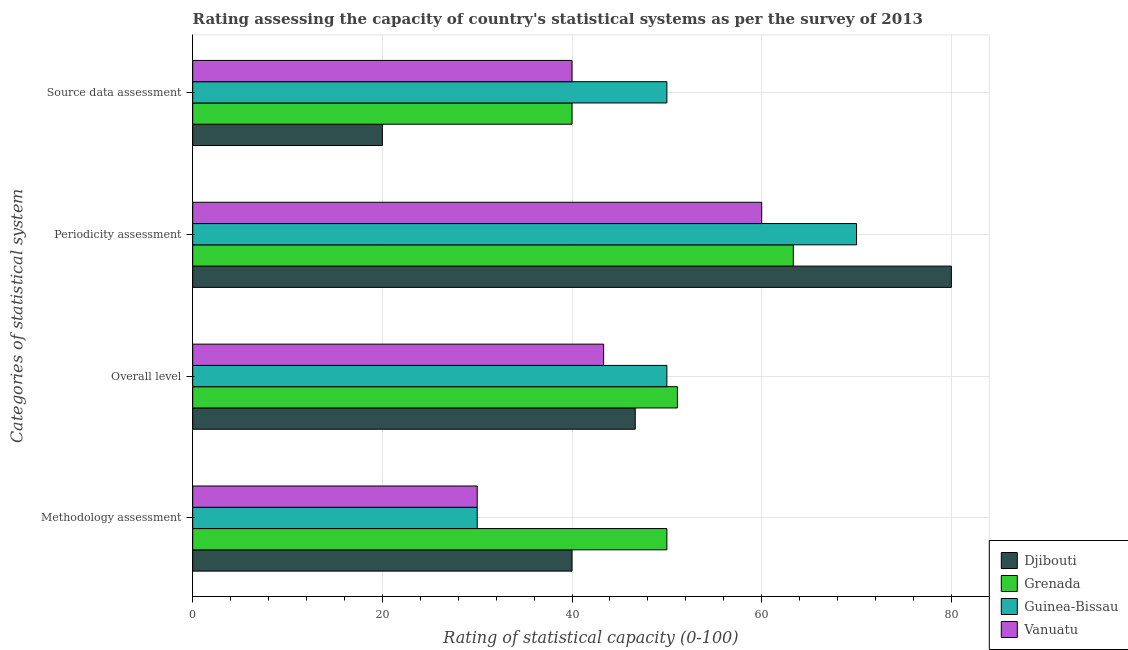How many different coloured bars are there?
Offer a very short reply. 4. Are the number of bars on each tick of the Y-axis equal?
Offer a terse response. Yes. How many bars are there on the 3rd tick from the top?
Your response must be concise. 4. How many bars are there on the 4th tick from the bottom?
Keep it short and to the point. 4. What is the label of the 1st group of bars from the top?
Provide a short and direct response. Source data assessment. What is the overall level rating in Grenada?
Provide a short and direct response. 51.11. Across all countries, what is the maximum methodology assessment rating?
Make the answer very short. 50. Across all countries, what is the minimum source data assessment rating?
Your answer should be very brief. 20. In which country was the methodology assessment rating maximum?
Offer a terse response. Grenada. In which country was the overall level rating minimum?
Provide a succinct answer. Vanuatu. What is the total methodology assessment rating in the graph?
Ensure brevity in your answer.  150. What is the difference between the source data assessment rating in Guinea-Bissau and that in Vanuatu?
Keep it short and to the point. 10. What is the difference between the methodology assessment rating in Vanuatu and the overall level rating in Grenada?
Offer a terse response. -21.11. What is the average overall level rating per country?
Provide a succinct answer. 47.78. What is the difference between the source data assessment rating and methodology assessment rating in Djibouti?
Provide a succinct answer. -20. What is the ratio of the methodology assessment rating in Grenada to that in Djibouti?
Ensure brevity in your answer.  1.25. Is the methodology assessment rating in Djibouti less than that in Guinea-Bissau?
Offer a very short reply. No. What is the difference between the highest and the second highest overall level rating?
Make the answer very short. 1.11. Is it the case that in every country, the sum of the source data assessment rating and periodicity assessment rating is greater than the sum of methodology assessment rating and overall level rating?
Offer a terse response. Yes. What does the 1st bar from the top in Methodology assessment represents?
Provide a short and direct response. Vanuatu. What does the 4th bar from the bottom in Overall level represents?
Your answer should be compact. Vanuatu. Are all the bars in the graph horizontal?
Keep it short and to the point. Yes. How many countries are there in the graph?
Your response must be concise. 4. What is the difference between two consecutive major ticks on the X-axis?
Offer a terse response. 20. Are the values on the major ticks of X-axis written in scientific E-notation?
Provide a succinct answer. No. Does the graph contain any zero values?
Keep it short and to the point. No. What is the title of the graph?
Ensure brevity in your answer.  Rating assessing the capacity of country's statistical systems as per the survey of 2013 . What is the label or title of the X-axis?
Your answer should be compact. Rating of statistical capacity (0-100). What is the label or title of the Y-axis?
Give a very brief answer. Categories of statistical system. What is the Rating of statistical capacity (0-100) in Djibouti in Methodology assessment?
Provide a succinct answer. 40. What is the Rating of statistical capacity (0-100) of Guinea-Bissau in Methodology assessment?
Offer a very short reply. 30. What is the Rating of statistical capacity (0-100) of Djibouti in Overall level?
Make the answer very short. 46.67. What is the Rating of statistical capacity (0-100) in Grenada in Overall level?
Your answer should be very brief. 51.11. What is the Rating of statistical capacity (0-100) in Guinea-Bissau in Overall level?
Provide a succinct answer. 50. What is the Rating of statistical capacity (0-100) of Vanuatu in Overall level?
Your response must be concise. 43.33. What is the Rating of statistical capacity (0-100) of Grenada in Periodicity assessment?
Your answer should be very brief. 63.33. What is the Rating of statistical capacity (0-100) of Djibouti in Source data assessment?
Your answer should be compact. 20. What is the Rating of statistical capacity (0-100) in Vanuatu in Source data assessment?
Give a very brief answer. 40. Across all Categories of statistical system, what is the maximum Rating of statistical capacity (0-100) of Djibouti?
Your answer should be compact. 80. Across all Categories of statistical system, what is the maximum Rating of statistical capacity (0-100) of Grenada?
Your response must be concise. 63.33. Across all Categories of statistical system, what is the maximum Rating of statistical capacity (0-100) of Guinea-Bissau?
Make the answer very short. 70. Across all Categories of statistical system, what is the maximum Rating of statistical capacity (0-100) of Vanuatu?
Ensure brevity in your answer.  60. What is the total Rating of statistical capacity (0-100) of Djibouti in the graph?
Your answer should be compact. 186.67. What is the total Rating of statistical capacity (0-100) of Grenada in the graph?
Provide a succinct answer. 204.44. What is the total Rating of statistical capacity (0-100) in Guinea-Bissau in the graph?
Your answer should be very brief. 200. What is the total Rating of statistical capacity (0-100) in Vanuatu in the graph?
Ensure brevity in your answer.  173.33. What is the difference between the Rating of statistical capacity (0-100) of Djibouti in Methodology assessment and that in Overall level?
Provide a succinct answer. -6.67. What is the difference between the Rating of statistical capacity (0-100) in Grenada in Methodology assessment and that in Overall level?
Ensure brevity in your answer.  -1.11. What is the difference between the Rating of statistical capacity (0-100) in Guinea-Bissau in Methodology assessment and that in Overall level?
Make the answer very short. -20. What is the difference between the Rating of statistical capacity (0-100) in Vanuatu in Methodology assessment and that in Overall level?
Your answer should be very brief. -13.33. What is the difference between the Rating of statistical capacity (0-100) of Grenada in Methodology assessment and that in Periodicity assessment?
Your response must be concise. -13.33. What is the difference between the Rating of statistical capacity (0-100) in Guinea-Bissau in Methodology assessment and that in Periodicity assessment?
Your answer should be compact. -40. What is the difference between the Rating of statistical capacity (0-100) in Vanuatu in Methodology assessment and that in Periodicity assessment?
Provide a short and direct response. -30. What is the difference between the Rating of statistical capacity (0-100) of Djibouti in Overall level and that in Periodicity assessment?
Give a very brief answer. -33.33. What is the difference between the Rating of statistical capacity (0-100) in Grenada in Overall level and that in Periodicity assessment?
Keep it short and to the point. -12.22. What is the difference between the Rating of statistical capacity (0-100) of Vanuatu in Overall level and that in Periodicity assessment?
Provide a succinct answer. -16.67. What is the difference between the Rating of statistical capacity (0-100) in Djibouti in Overall level and that in Source data assessment?
Offer a terse response. 26.67. What is the difference between the Rating of statistical capacity (0-100) in Grenada in Overall level and that in Source data assessment?
Provide a succinct answer. 11.11. What is the difference between the Rating of statistical capacity (0-100) of Guinea-Bissau in Overall level and that in Source data assessment?
Provide a short and direct response. 0. What is the difference between the Rating of statistical capacity (0-100) of Vanuatu in Overall level and that in Source data assessment?
Your answer should be compact. 3.33. What is the difference between the Rating of statistical capacity (0-100) in Djibouti in Periodicity assessment and that in Source data assessment?
Your response must be concise. 60. What is the difference between the Rating of statistical capacity (0-100) in Grenada in Periodicity assessment and that in Source data assessment?
Offer a terse response. 23.33. What is the difference between the Rating of statistical capacity (0-100) in Guinea-Bissau in Periodicity assessment and that in Source data assessment?
Give a very brief answer. 20. What is the difference between the Rating of statistical capacity (0-100) of Djibouti in Methodology assessment and the Rating of statistical capacity (0-100) of Grenada in Overall level?
Ensure brevity in your answer.  -11.11. What is the difference between the Rating of statistical capacity (0-100) of Djibouti in Methodology assessment and the Rating of statistical capacity (0-100) of Vanuatu in Overall level?
Provide a short and direct response. -3.33. What is the difference between the Rating of statistical capacity (0-100) in Grenada in Methodology assessment and the Rating of statistical capacity (0-100) in Vanuatu in Overall level?
Give a very brief answer. 6.67. What is the difference between the Rating of statistical capacity (0-100) in Guinea-Bissau in Methodology assessment and the Rating of statistical capacity (0-100) in Vanuatu in Overall level?
Give a very brief answer. -13.33. What is the difference between the Rating of statistical capacity (0-100) of Djibouti in Methodology assessment and the Rating of statistical capacity (0-100) of Grenada in Periodicity assessment?
Offer a terse response. -23.33. What is the difference between the Rating of statistical capacity (0-100) of Grenada in Methodology assessment and the Rating of statistical capacity (0-100) of Guinea-Bissau in Periodicity assessment?
Offer a very short reply. -20. What is the difference between the Rating of statistical capacity (0-100) in Grenada in Methodology assessment and the Rating of statistical capacity (0-100) in Vanuatu in Periodicity assessment?
Give a very brief answer. -10. What is the difference between the Rating of statistical capacity (0-100) in Guinea-Bissau in Methodology assessment and the Rating of statistical capacity (0-100) in Vanuatu in Periodicity assessment?
Your answer should be very brief. -30. What is the difference between the Rating of statistical capacity (0-100) of Djibouti in Methodology assessment and the Rating of statistical capacity (0-100) of Guinea-Bissau in Source data assessment?
Provide a succinct answer. -10. What is the difference between the Rating of statistical capacity (0-100) in Djibouti in Methodology assessment and the Rating of statistical capacity (0-100) in Vanuatu in Source data assessment?
Provide a short and direct response. 0. What is the difference between the Rating of statistical capacity (0-100) of Djibouti in Overall level and the Rating of statistical capacity (0-100) of Grenada in Periodicity assessment?
Offer a terse response. -16.67. What is the difference between the Rating of statistical capacity (0-100) of Djibouti in Overall level and the Rating of statistical capacity (0-100) of Guinea-Bissau in Periodicity assessment?
Give a very brief answer. -23.33. What is the difference between the Rating of statistical capacity (0-100) in Djibouti in Overall level and the Rating of statistical capacity (0-100) in Vanuatu in Periodicity assessment?
Your response must be concise. -13.33. What is the difference between the Rating of statistical capacity (0-100) of Grenada in Overall level and the Rating of statistical capacity (0-100) of Guinea-Bissau in Periodicity assessment?
Your response must be concise. -18.89. What is the difference between the Rating of statistical capacity (0-100) of Grenada in Overall level and the Rating of statistical capacity (0-100) of Vanuatu in Periodicity assessment?
Make the answer very short. -8.89. What is the difference between the Rating of statistical capacity (0-100) in Guinea-Bissau in Overall level and the Rating of statistical capacity (0-100) in Vanuatu in Periodicity assessment?
Offer a very short reply. -10. What is the difference between the Rating of statistical capacity (0-100) of Grenada in Overall level and the Rating of statistical capacity (0-100) of Guinea-Bissau in Source data assessment?
Keep it short and to the point. 1.11. What is the difference between the Rating of statistical capacity (0-100) of Grenada in Overall level and the Rating of statistical capacity (0-100) of Vanuatu in Source data assessment?
Make the answer very short. 11.11. What is the difference between the Rating of statistical capacity (0-100) of Djibouti in Periodicity assessment and the Rating of statistical capacity (0-100) of Grenada in Source data assessment?
Give a very brief answer. 40. What is the difference between the Rating of statistical capacity (0-100) of Djibouti in Periodicity assessment and the Rating of statistical capacity (0-100) of Guinea-Bissau in Source data assessment?
Your answer should be very brief. 30. What is the difference between the Rating of statistical capacity (0-100) in Djibouti in Periodicity assessment and the Rating of statistical capacity (0-100) in Vanuatu in Source data assessment?
Give a very brief answer. 40. What is the difference between the Rating of statistical capacity (0-100) in Grenada in Periodicity assessment and the Rating of statistical capacity (0-100) in Guinea-Bissau in Source data assessment?
Give a very brief answer. 13.33. What is the difference between the Rating of statistical capacity (0-100) of Grenada in Periodicity assessment and the Rating of statistical capacity (0-100) of Vanuatu in Source data assessment?
Ensure brevity in your answer.  23.33. What is the difference between the Rating of statistical capacity (0-100) in Guinea-Bissau in Periodicity assessment and the Rating of statistical capacity (0-100) in Vanuatu in Source data assessment?
Offer a terse response. 30. What is the average Rating of statistical capacity (0-100) in Djibouti per Categories of statistical system?
Make the answer very short. 46.67. What is the average Rating of statistical capacity (0-100) of Grenada per Categories of statistical system?
Ensure brevity in your answer.  51.11. What is the average Rating of statistical capacity (0-100) of Vanuatu per Categories of statistical system?
Your answer should be compact. 43.33. What is the difference between the Rating of statistical capacity (0-100) in Djibouti and Rating of statistical capacity (0-100) in Grenada in Methodology assessment?
Offer a very short reply. -10. What is the difference between the Rating of statistical capacity (0-100) in Djibouti and Rating of statistical capacity (0-100) in Guinea-Bissau in Methodology assessment?
Make the answer very short. 10. What is the difference between the Rating of statistical capacity (0-100) in Djibouti and Rating of statistical capacity (0-100) in Grenada in Overall level?
Offer a terse response. -4.44. What is the difference between the Rating of statistical capacity (0-100) in Djibouti and Rating of statistical capacity (0-100) in Guinea-Bissau in Overall level?
Your answer should be compact. -3.33. What is the difference between the Rating of statistical capacity (0-100) of Djibouti and Rating of statistical capacity (0-100) of Vanuatu in Overall level?
Make the answer very short. 3.33. What is the difference between the Rating of statistical capacity (0-100) of Grenada and Rating of statistical capacity (0-100) of Guinea-Bissau in Overall level?
Your answer should be compact. 1.11. What is the difference between the Rating of statistical capacity (0-100) in Grenada and Rating of statistical capacity (0-100) in Vanuatu in Overall level?
Provide a short and direct response. 7.78. What is the difference between the Rating of statistical capacity (0-100) in Djibouti and Rating of statistical capacity (0-100) in Grenada in Periodicity assessment?
Your answer should be very brief. 16.67. What is the difference between the Rating of statistical capacity (0-100) in Grenada and Rating of statistical capacity (0-100) in Guinea-Bissau in Periodicity assessment?
Your answer should be compact. -6.67. What is the difference between the Rating of statistical capacity (0-100) of Grenada and Rating of statistical capacity (0-100) of Vanuatu in Periodicity assessment?
Your answer should be very brief. 3.33. What is the difference between the Rating of statistical capacity (0-100) in Djibouti and Rating of statistical capacity (0-100) in Grenada in Source data assessment?
Make the answer very short. -20. What is the difference between the Rating of statistical capacity (0-100) of Grenada and Rating of statistical capacity (0-100) of Guinea-Bissau in Source data assessment?
Keep it short and to the point. -10. What is the ratio of the Rating of statistical capacity (0-100) of Grenada in Methodology assessment to that in Overall level?
Ensure brevity in your answer.  0.98. What is the ratio of the Rating of statistical capacity (0-100) in Guinea-Bissau in Methodology assessment to that in Overall level?
Your response must be concise. 0.6. What is the ratio of the Rating of statistical capacity (0-100) of Vanuatu in Methodology assessment to that in Overall level?
Provide a short and direct response. 0.69. What is the ratio of the Rating of statistical capacity (0-100) of Djibouti in Methodology assessment to that in Periodicity assessment?
Your answer should be compact. 0.5. What is the ratio of the Rating of statistical capacity (0-100) of Grenada in Methodology assessment to that in Periodicity assessment?
Your response must be concise. 0.79. What is the ratio of the Rating of statistical capacity (0-100) in Guinea-Bissau in Methodology assessment to that in Periodicity assessment?
Keep it short and to the point. 0.43. What is the ratio of the Rating of statistical capacity (0-100) in Vanuatu in Methodology assessment to that in Periodicity assessment?
Offer a very short reply. 0.5. What is the ratio of the Rating of statistical capacity (0-100) in Djibouti in Overall level to that in Periodicity assessment?
Offer a very short reply. 0.58. What is the ratio of the Rating of statistical capacity (0-100) in Grenada in Overall level to that in Periodicity assessment?
Ensure brevity in your answer.  0.81. What is the ratio of the Rating of statistical capacity (0-100) in Vanuatu in Overall level to that in Periodicity assessment?
Your answer should be very brief. 0.72. What is the ratio of the Rating of statistical capacity (0-100) of Djibouti in Overall level to that in Source data assessment?
Provide a short and direct response. 2.33. What is the ratio of the Rating of statistical capacity (0-100) in Grenada in Overall level to that in Source data assessment?
Your answer should be very brief. 1.28. What is the ratio of the Rating of statistical capacity (0-100) of Guinea-Bissau in Overall level to that in Source data assessment?
Make the answer very short. 1. What is the ratio of the Rating of statistical capacity (0-100) in Vanuatu in Overall level to that in Source data assessment?
Offer a terse response. 1.08. What is the ratio of the Rating of statistical capacity (0-100) in Grenada in Periodicity assessment to that in Source data assessment?
Offer a terse response. 1.58. What is the ratio of the Rating of statistical capacity (0-100) of Guinea-Bissau in Periodicity assessment to that in Source data assessment?
Provide a short and direct response. 1.4. What is the ratio of the Rating of statistical capacity (0-100) in Vanuatu in Periodicity assessment to that in Source data assessment?
Give a very brief answer. 1.5. What is the difference between the highest and the second highest Rating of statistical capacity (0-100) in Djibouti?
Offer a terse response. 33.33. What is the difference between the highest and the second highest Rating of statistical capacity (0-100) in Grenada?
Offer a very short reply. 12.22. What is the difference between the highest and the second highest Rating of statistical capacity (0-100) in Vanuatu?
Offer a very short reply. 16.67. What is the difference between the highest and the lowest Rating of statistical capacity (0-100) of Grenada?
Your response must be concise. 23.33. 